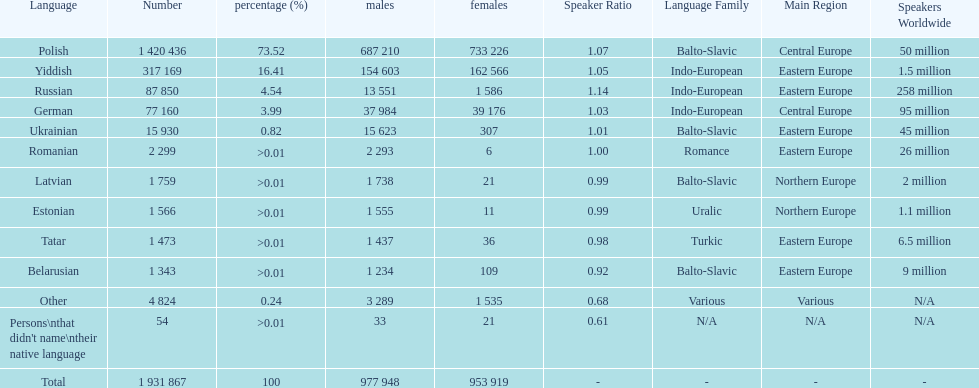In terms of language speakers, is german higher or lower than russian? Below. 